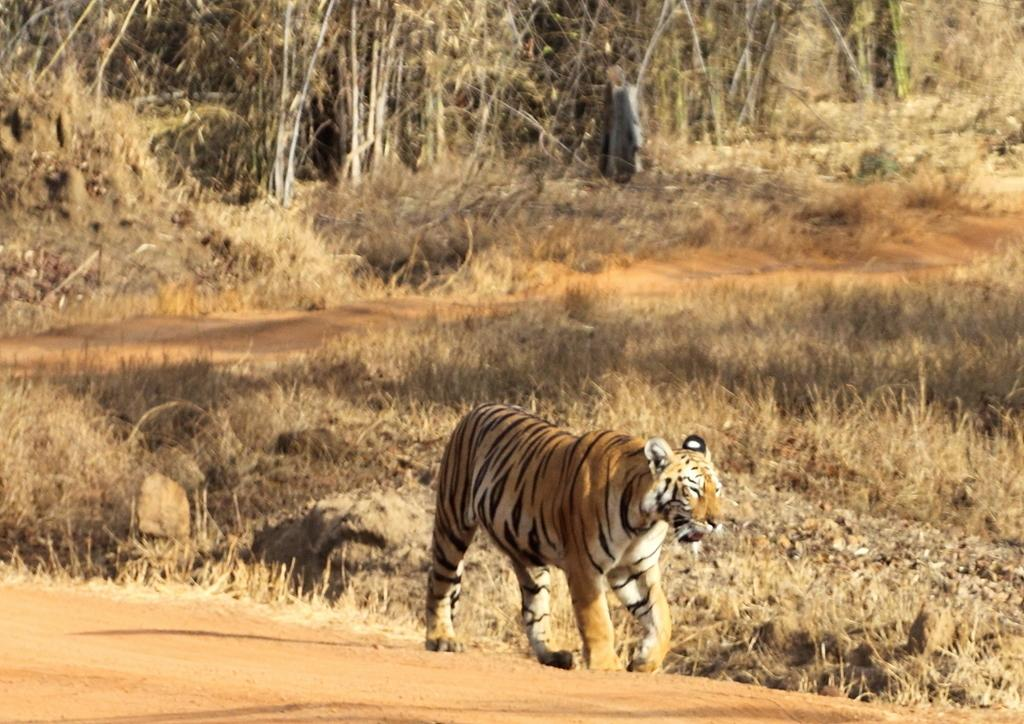What animal is in the image? There is a tiger in the image. What colors can be seen on the tiger? The tiger is brown, black, and cream in color. What is the tiger standing on? The tiger is standing on the ground. What type of vegetation is visible in the background of the image? There is grass visible in the background of the image. What other natural elements can be seen in the background of the image? There are trees in the background of the image. Where is the rake being used in the image? There is no rake present in the image. What type of slope can be seen in the image? There is no slope visible in the image. 